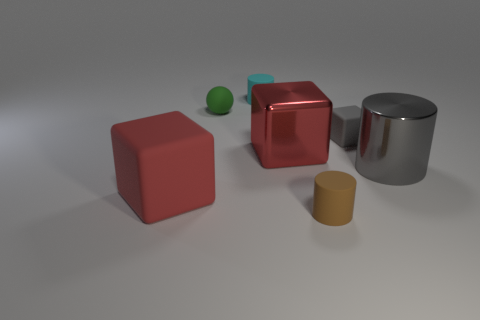Do the large shiny block that is to the right of the cyan matte cylinder and the big rubber thing have the same color?
Offer a terse response. Yes. What number of cylinders are either red metal objects or brown matte things?
Provide a succinct answer. 1. What is the size of the red matte block that is in front of the small green sphere behind the red object that is to the right of the tiny rubber sphere?
Give a very brief answer. Large. What shape is the brown object that is the same size as the sphere?
Offer a very short reply. Cylinder. There is a brown matte thing; what shape is it?
Keep it short and to the point. Cylinder. Do the tiny cylinder that is in front of the small cyan rubber object and the large cylinder have the same material?
Make the answer very short. No. What is the size of the rubber cylinder behind the tiny matte cylinder that is in front of the red rubber thing?
Your response must be concise. Small. What is the color of the rubber object that is behind the large red metal object and to the left of the cyan rubber thing?
Offer a very short reply. Green. There is a gray cylinder that is the same size as the metal cube; what material is it?
Ensure brevity in your answer.  Metal. How many other objects are there of the same material as the large gray object?
Make the answer very short. 1. 